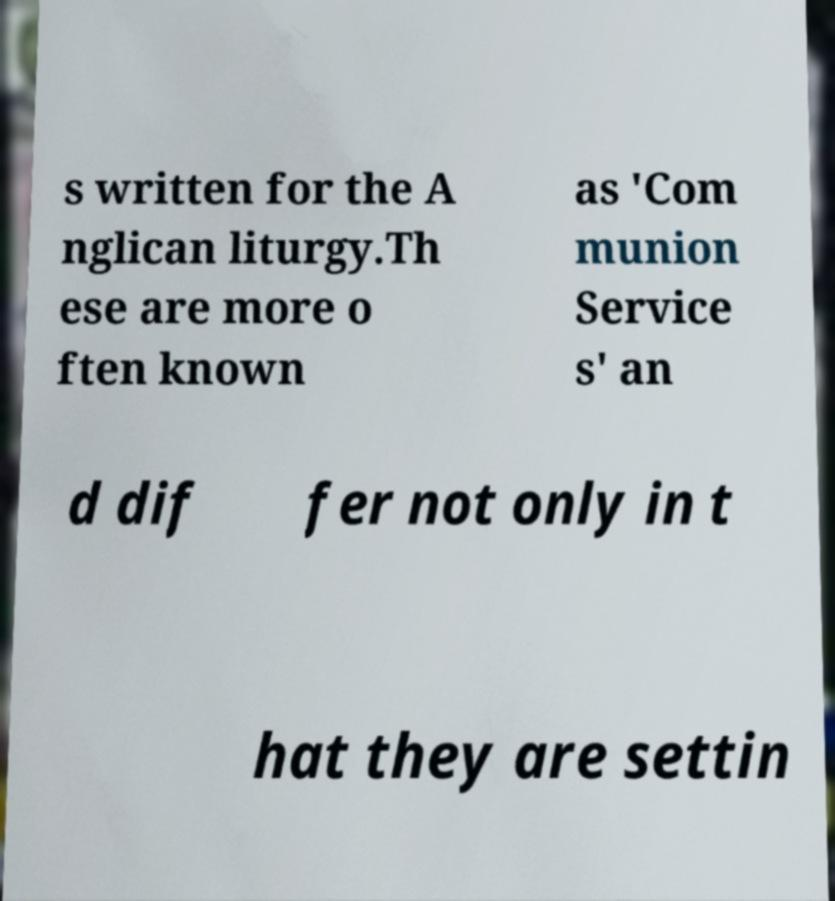Can you accurately transcribe the text from the provided image for me? s written for the A nglican liturgy.Th ese are more o ften known as 'Com munion Service s' an d dif fer not only in t hat they are settin 